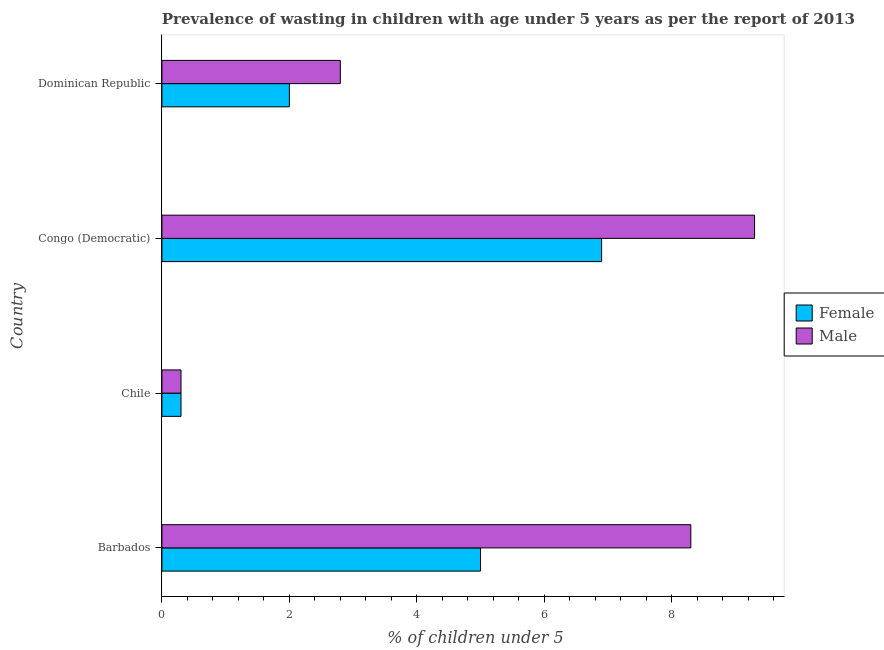How many different coloured bars are there?
Your answer should be very brief. 2. Are the number of bars per tick equal to the number of legend labels?
Make the answer very short. Yes. Are the number of bars on each tick of the Y-axis equal?
Keep it short and to the point. Yes. What is the label of the 4th group of bars from the top?
Your answer should be very brief. Barbados. In how many cases, is the number of bars for a given country not equal to the number of legend labels?
Your response must be concise. 0. What is the percentage of undernourished female children in Barbados?
Keep it short and to the point. 5. Across all countries, what is the maximum percentage of undernourished male children?
Your answer should be very brief. 9.3. Across all countries, what is the minimum percentage of undernourished female children?
Offer a terse response. 0.3. In which country was the percentage of undernourished male children maximum?
Your answer should be very brief. Congo (Democratic). What is the total percentage of undernourished male children in the graph?
Your response must be concise. 20.7. What is the difference between the percentage of undernourished female children in Dominican Republic and the percentage of undernourished male children in Chile?
Your answer should be compact. 1.7. What is the average percentage of undernourished female children per country?
Your answer should be compact. 3.55. What is the difference between the percentage of undernourished male children and percentage of undernourished female children in Congo (Democratic)?
Provide a short and direct response. 2.4. What is the ratio of the percentage of undernourished male children in Barbados to that in Chile?
Keep it short and to the point. 27.67. Is the percentage of undernourished male children in Congo (Democratic) less than that in Dominican Republic?
Your answer should be very brief. No. What is the difference between the highest and the lowest percentage of undernourished female children?
Provide a short and direct response. 6.6. What does the 2nd bar from the bottom in Barbados represents?
Your response must be concise. Male. How many bars are there?
Provide a short and direct response. 8. How many countries are there in the graph?
Your answer should be very brief. 4. What is the difference between two consecutive major ticks on the X-axis?
Offer a terse response. 2. Does the graph contain any zero values?
Your answer should be compact. No. How are the legend labels stacked?
Your answer should be very brief. Vertical. What is the title of the graph?
Offer a terse response. Prevalence of wasting in children with age under 5 years as per the report of 2013. What is the label or title of the X-axis?
Ensure brevity in your answer.   % of children under 5. What is the  % of children under 5 of Male in Barbados?
Keep it short and to the point. 8.3. What is the  % of children under 5 in Female in Chile?
Provide a short and direct response. 0.3. What is the  % of children under 5 in Male in Chile?
Offer a very short reply. 0.3. What is the  % of children under 5 of Female in Congo (Democratic)?
Offer a very short reply. 6.9. What is the  % of children under 5 of Male in Congo (Democratic)?
Your response must be concise. 9.3. What is the  % of children under 5 in Female in Dominican Republic?
Make the answer very short. 2. What is the  % of children under 5 of Male in Dominican Republic?
Ensure brevity in your answer.  2.8. Across all countries, what is the maximum  % of children under 5 of Female?
Keep it short and to the point. 6.9. Across all countries, what is the maximum  % of children under 5 in Male?
Keep it short and to the point. 9.3. Across all countries, what is the minimum  % of children under 5 in Female?
Give a very brief answer. 0.3. Across all countries, what is the minimum  % of children under 5 of Male?
Provide a succinct answer. 0.3. What is the total  % of children under 5 of Female in the graph?
Give a very brief answer. 14.2. What is the total  % of children under 5 in Male in the graph?
Ensure brevity in your answer.  20.7. What is the difference between the  % of children under 5 of Male in Barbados and that in Chile?
Provide a succinct answer. 8. What is the difference between the  % of children under 5 of Male in Barbados and that in Dominican Republic?
Give a very brief answer. 5.5. What is the difference between the  % of children under 5 of Female in Chile and that in Congo (Democratic)?
Ensure brevity in your answer.  -6.6. What is the difference between the  % of children under 5 in Male in Chile and that in Congo (Democratic)?
Give a very brief answer. -9. What is the difference between the  % of children under 5 of Male in Chile and that in Dominican Republic?
Your answer should be very brief. -2.5. What is the difference between the  % of children under 5 of Female in Barbados and the  % of children under 5 of Male in Chile?
Provide a succinct answer. 4.7. What is the difference between the  % of children under 5 in Female in Barbados and the  % of children under 5 in Male in Dominican Republic?
Offer a terse response. 2.2. What is the difference between the  % of children under 5 in Female in Congo (Democratic) and the  % of children under 5 in Male in Dominican Republic?
Your answer should be compact. 4.1. What is the average  % of children under 5 in Female per country?
Your answer should be compact. 3.55. What is the average  % of children under 5 in Male per country?
Keep it short and to the point. 5.17. What is the difference between the  % of children under 5 of Female and  % of children under 5 of Male in Chile?
Provide a short and direct response. 0. What is the difference between the  % of children under 5 in Female and  % of children under 5 in Male in Congo (Democratic)?
Offer a terse response. -2.4. What is the ratio of the  % of children under 5 in Female in Barbados to that in Chile?
Your response must be concise. 16.67. What is the ratio of the  % of children under 5 of Male in Barbados to that in Chile?
Offer a terse response. 27.67. What is the ratio of the  % of children under 5 of Female in Barbados to that in Congo (Democratic)?
Keep it short and to the point. 0.72. What is the ratio of the  % of children under 5 in Male in Barbados to that in Congo (Democratic)?
Offer a terse response. 0.89. What is the ratio of the  % of children under 5 of Female in Barbados to that in Dominican Republic?
Offer a terse response. 2.5. What is the ratio of the  % of children under 5 of Male in Barbados to that in Dominican Republic?
Offer a very short reply. 2.96. What is the ratio of the  % of children under 5 in Female in Chile to that in Congo (Democratic)?
Make the answer very short. 0.04. What is the ratio of the  % of children under 5 in Male in Chile to that in Congo (Democratic)?
Give a very brief answer. 0.03. What is the ratio of the  % of children under 5 in Male in Chile to that in Dominican Republic?
Offer a terse response. 0.11. What is the ratio of the  % of children under 5 of Female in Congo (Democratic) to that in Dominican Republic?
Your answer should be very brief. 3.45. What is the ratio of the  % of children under 5 in Male in Congo (Democratic) to that in Dominican Republic?
Offer a terse response. 3.32. What is the difference between the highest and the second highest  % of children under 5 in Female?
Give a very brief answer. 1.9. What is the difference between the highest and the second highest  % of children under 5 of Male?
Offer a very short reply. 1. 